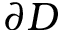Convert formula to latex. <formula><loc_0><loc_0><loc_500><loc_500>\partial { D }</formula> 